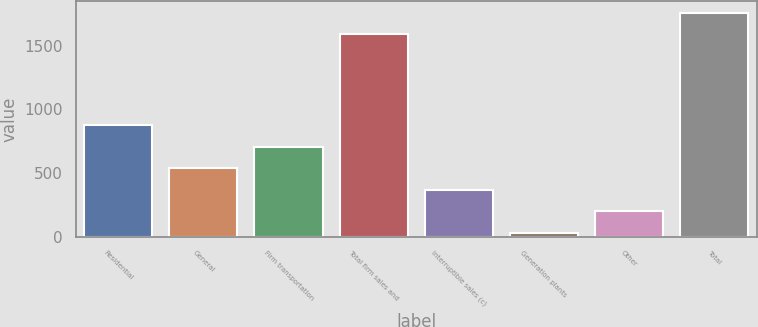Convert chart. <chart><loc_0><loc_0><loc_500><loc_500><bar_chart><fcel>Residential<fcel>General<fcel>Firm transportation<fcel>Total firm sales and<fcel>Interruptible sales (c)<fcel>Generation plants<fcel>Other<fcel>Total<nl><fcel>875.5<fcel>537.3<fcel>706.4<fcel>1594<fcel>368.2<fcel>30<fcel>199.1<fcel>1763.1<nl></chart> 